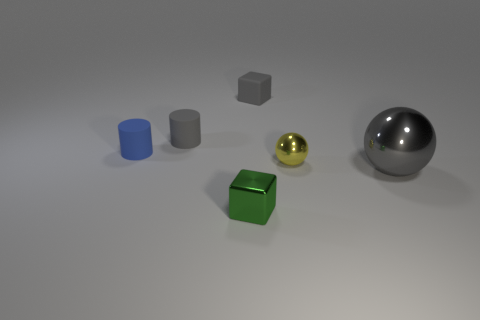Add 3 tiny purple spheres. How many objects exist? 9 Subtract all blocks. How many objects are left? 4 Subtract all small blue matte objects. Subtract all tiny matte blocks. How many objects are left? 4 Add 2 tiny yellow spheres. How many tiny yellow spheres are left? 3 Add 5 big brown cubes. How many big brown cubes exist? 5 Subtract 1 gray cylinders. How many objects are left? 5 Subtract all brown cubes. Subtract all brown balls. How many cubes are left? 2 